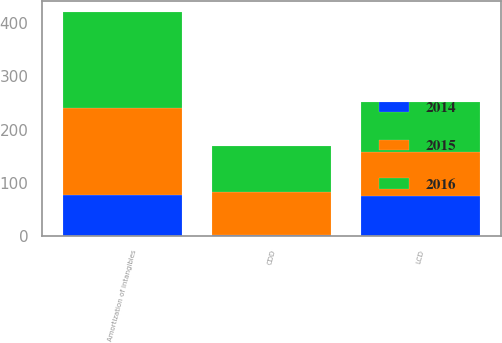Convert chart to OTSL. <chart><loc_0><loc_0><loc_500><loc_500><stacked_bar_chart><ecel><fcel>LCD<fcel>CDD<fcel>Amortization of intangibles<nl><fcel>2016<fcel>93.4<fcel>86.1<fcel>179.5<nl><fcel>2015<fcel>82.4<fcel>82.1<fcel>164.5<nl><fcel>2014<fcel>75.5<fcel>1.2<fcel>76.7<nl></chart> 